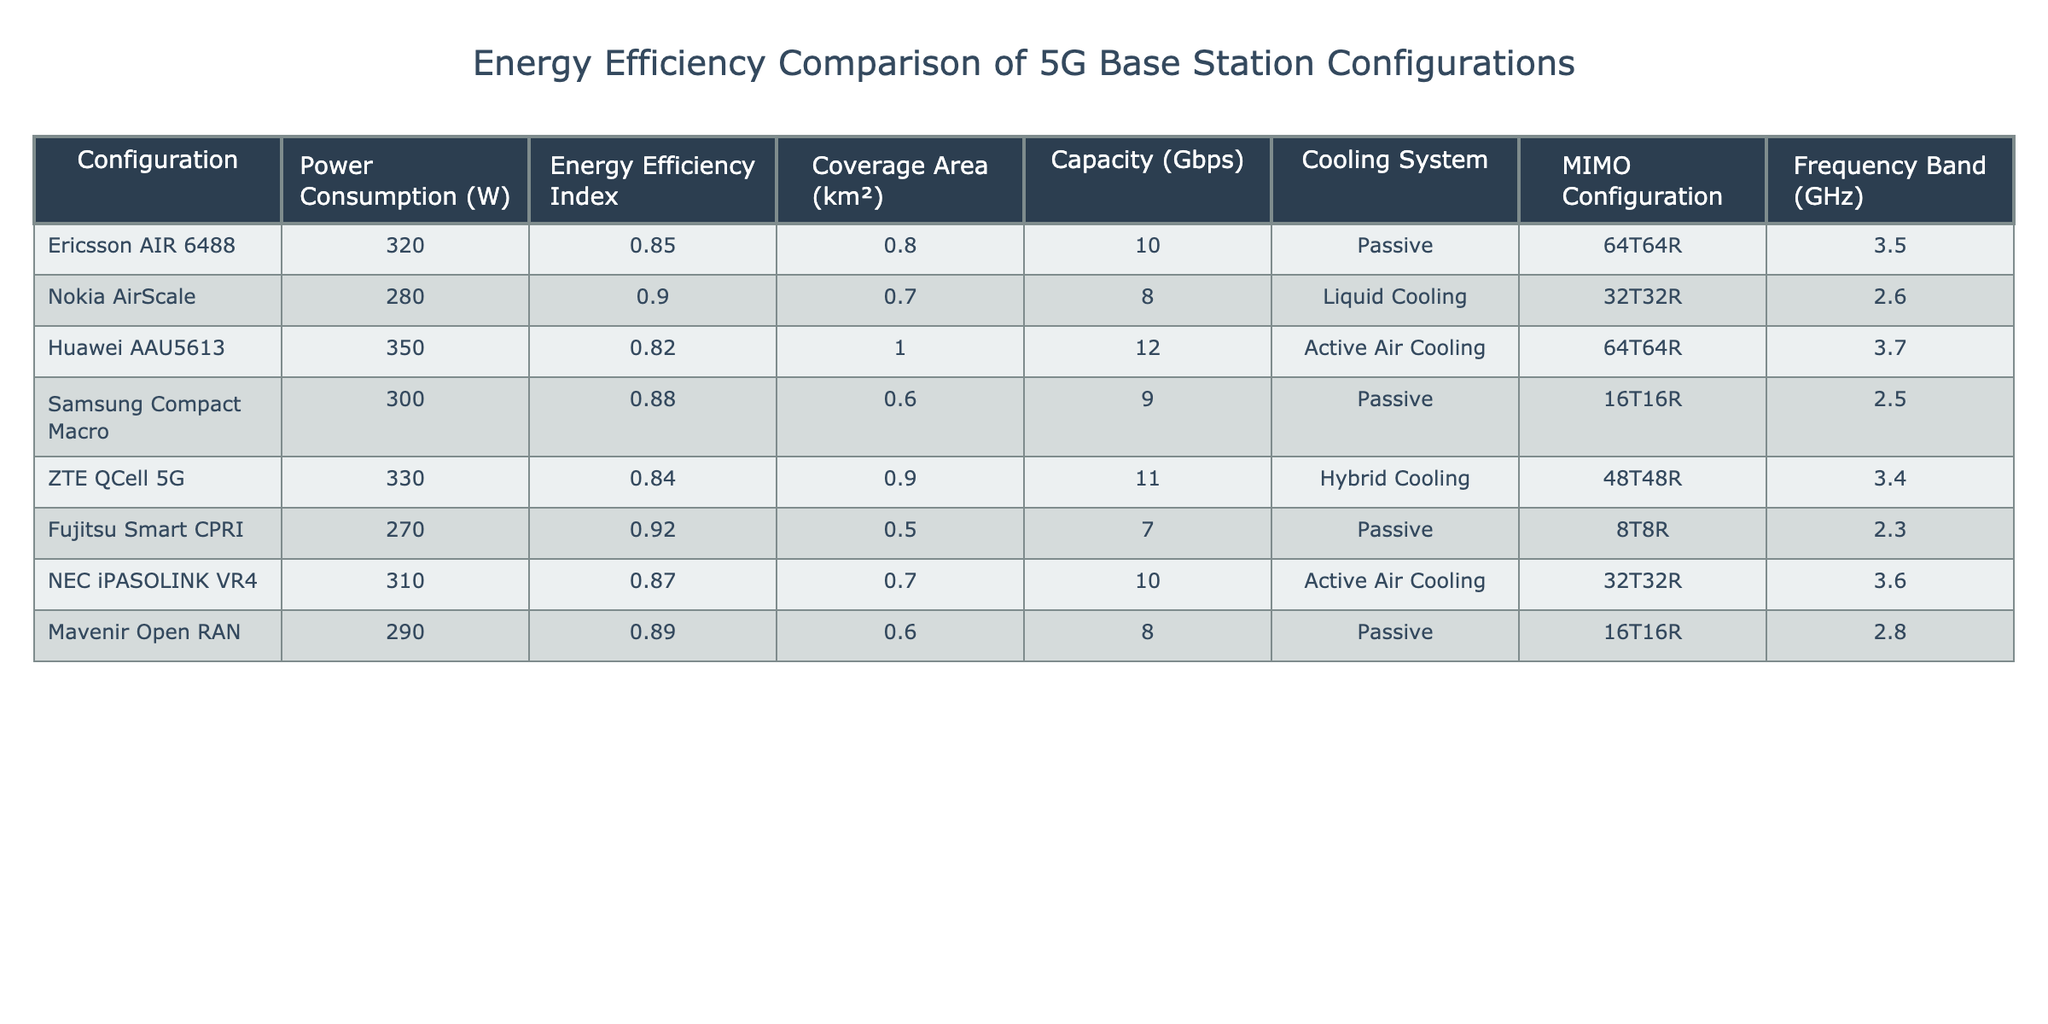What is the power consumption of the Huawei AAU5613 configuration? From the table, the power consumption value listed under the "Power Consumption (W)" column for Huawei AAU5613 is 350 W.
Answer: 350 W Which configuration has the highest Energy Efficiency Index? By examining the "Energy Efficiency Index" column, the highest value is found in the Fujitsu Smart CPRI configuration with an index of 0.92.
Answer: Fujitsu Smart CPRI What is the average power consumption of all listed configurations? To find the average, sum up the power consumption values: 320 + 280 + 350 + 300 + 330 + 270 + 310 + 290 = 2,200 W, then divide by the number of configurations (8): 2,200 / 8 = 275 W.
Answer: 275 W Does the ZTE QCell 5G configuration use a passive cooling system? Looking at the "Cooling System" column, the ZTE QCell 5G configuration is specified to use a Hybrid Cooling system, hence the answer is no.
Answer: No Which configuration offers the largest coverage area, and what is its value? The "Coverage Area (km²)" column shows the Huawei AAU5613 configuration with a coverage area value of 1.0 km², which is the largest compared to others in the table.
Answer: 1.0 km² Which configuration has the lowest power consumption, and what is its Energy Efficiency Index? The lowest power consumption is for Fujitsu Smart CPRI at 270 W. Its Energy Efficiency Index can be looked up in the same row, which is 0.92.
Answer: Fujitsu Smart CPRI, 0.92 If you wanted to compare capacities, how much greater is the capacity of the Huawei AAU5613 compared to the Samsung Compact Macro? The capacity for Huawei AAU5613 is 12 Gbps, and for Samsung Compact Macro, it is 9 Gbps. The difference in capacity is 12 - 9 = 3 Gbps.
Answer: 3 Gbps Can you list the configurations that have a higher capacity than 10 Gbps? By checking the "Capacity (Gbps)" column, the configurations that exceed 10 Gbps are the Huawei AAU5613 (12 Gbps) and ZTE QCell 5G (11 Gbps).
Answer: Huawei AAU5613, ZTE QCell 5G Is the cooling system for the Ericsson AIR 6488 configuration active? In reviewing the "Cooling System" column for the Ericsson AIR 6488, it is shown to have a Passive cooling system, so the statement is false.
Answer: No 